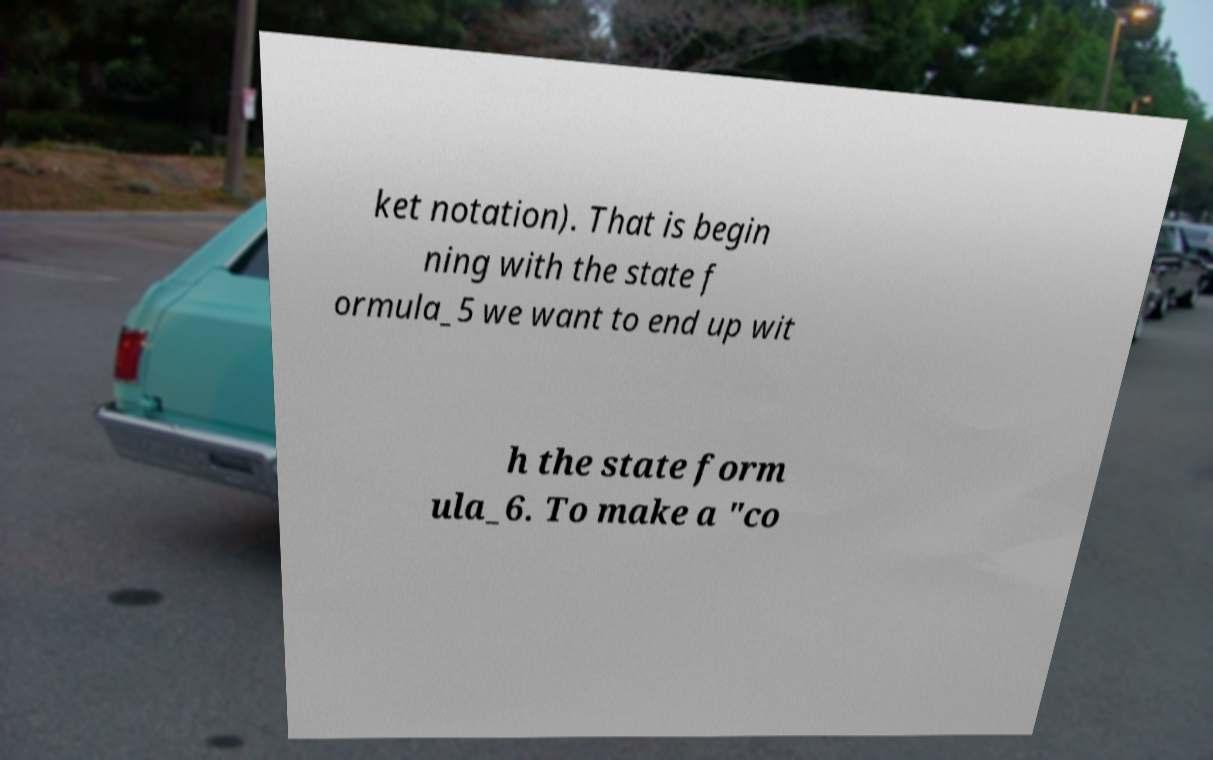Could you extract and type out the text from this image? ket notation). That is begin ning with the state f ormula_5 we want to end up wit h the state form ula_6. To make a "co 